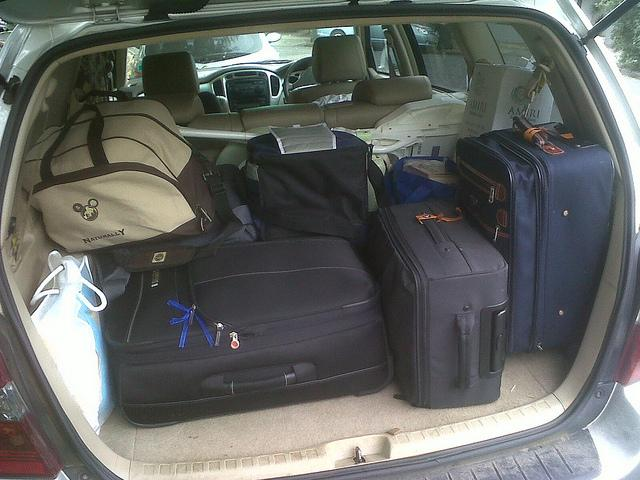Why would this person load the back of their car with these?

Choices:
A) delivery driver
B) work tools
C) road trip
D) add weight road trip 